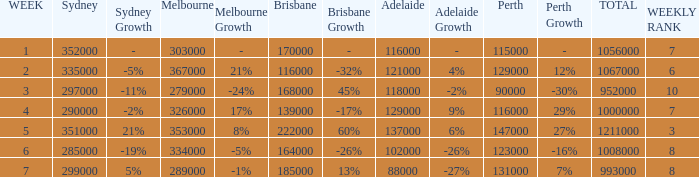What is the highest number of Brisbane viewers? 222000.0. 